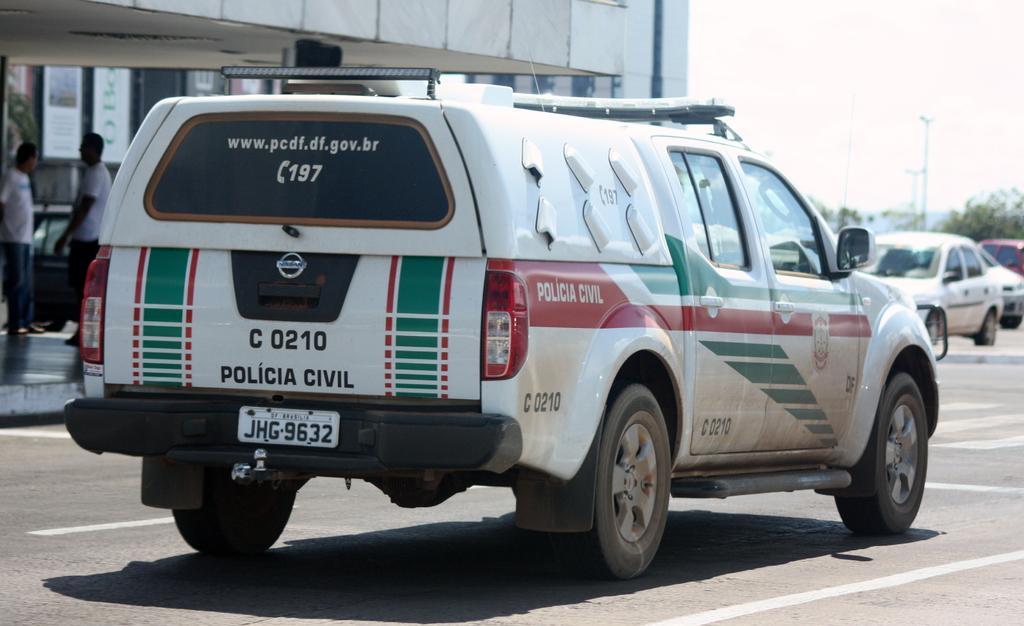Please provide a concise description of this image. In this picture I can see a vehicle in front and I can see something is written on it. On the left side of this picture I can see 2 persons. In the background I can see the trees, few poles and few more cars and I can also see a building. 